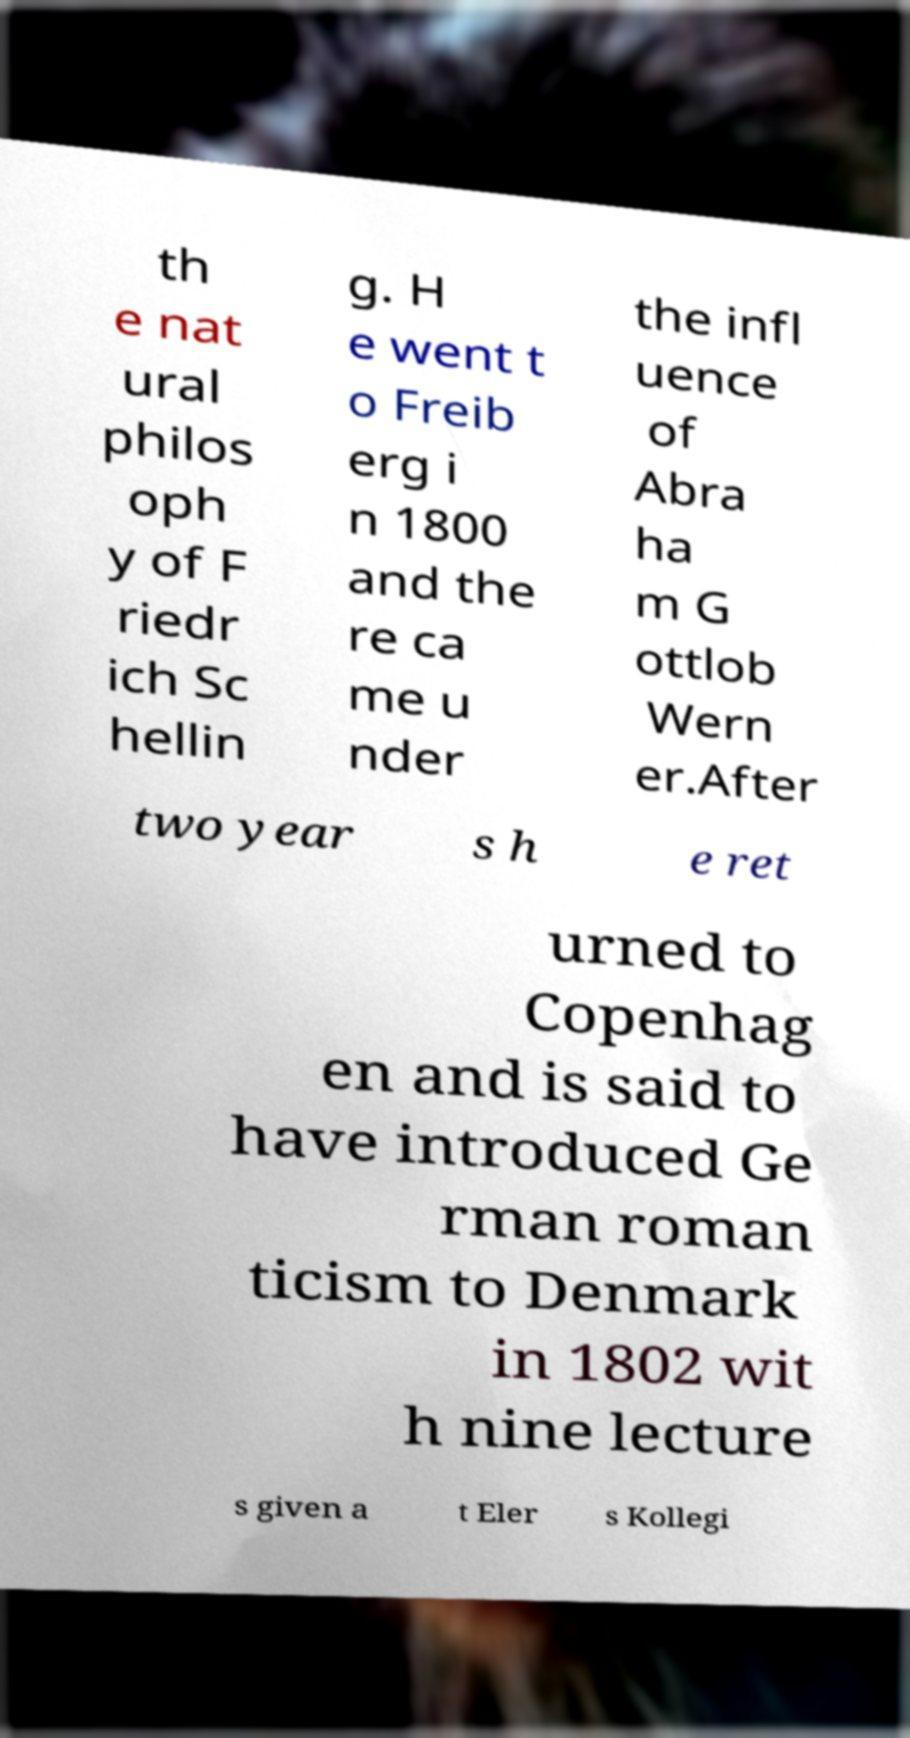Please identify and transcribe the text found in this image. th e nat ural philos oph y of F riedr ich Sc hellin g. H e went t o Freib erg i n 1800 and the re ca me u nder the infl uence of Abra ha m G ottlob Wern er.After two year s h e ret urned to Copenhag en and is said to have introduced Ge rman roman ticism to Denmark in 1802 wit h nine lecture s given a t Eler s Kollegi 